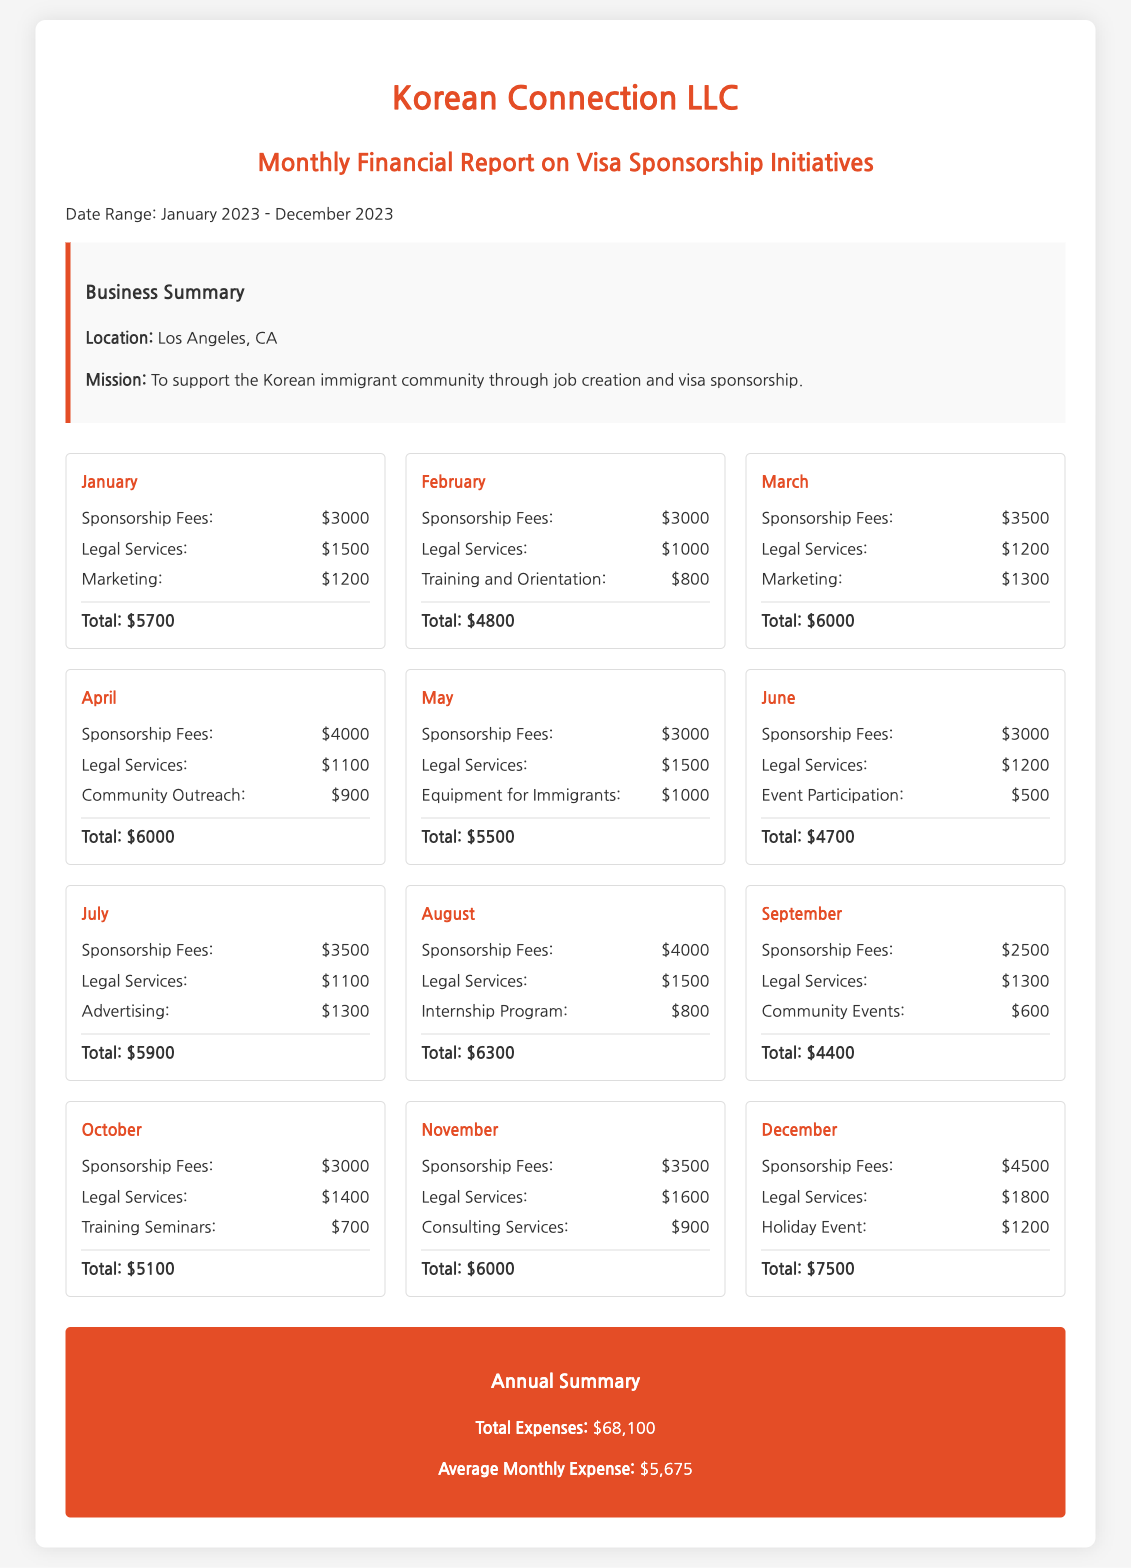what is the total expense for January? The total expense for January is explicitly listed in the document as $5700.
Answer: $5700 what was the expense on Marketing in March? The expense on Marketing for March is shown as $1300 in the document.
Answer: $1300 which month had the highest total expenses? A comparison of total expenses shows that December has the highest total expenses at $7500.
Answer: December what is the average monthly expense? The average monthly expense is calculated from the total expenses of $68,100 divided by 12 months, resulting in $5,675.
Answer: $5,675 how much was spent on Legal Services in November? The document states that Legal Services cost $1600 in November.
Answer: $1600 which expenses were listed under the month of July? The expenses for July include Sponsorship Fees, Legal Services, and Advertising, with amounts of $3500, $1100, and $1300 respectively.
Answer: Sponsorship Fees, Legal Services, Advertising what was the purpose of the community outreach in April? The document lists Community Outreach as an expense category but does not specify its purpose. Therefore, the context is not available in the document.
Answer: Not specified how many categories of expenses are there in total? By counting the unique expense categories across all months, there are eight distinct categories mentioned in the document.
Answer: Eight what was the total expense for the month of September? The document clearly states that the total expense for September is $4400.
Answer: $4400 